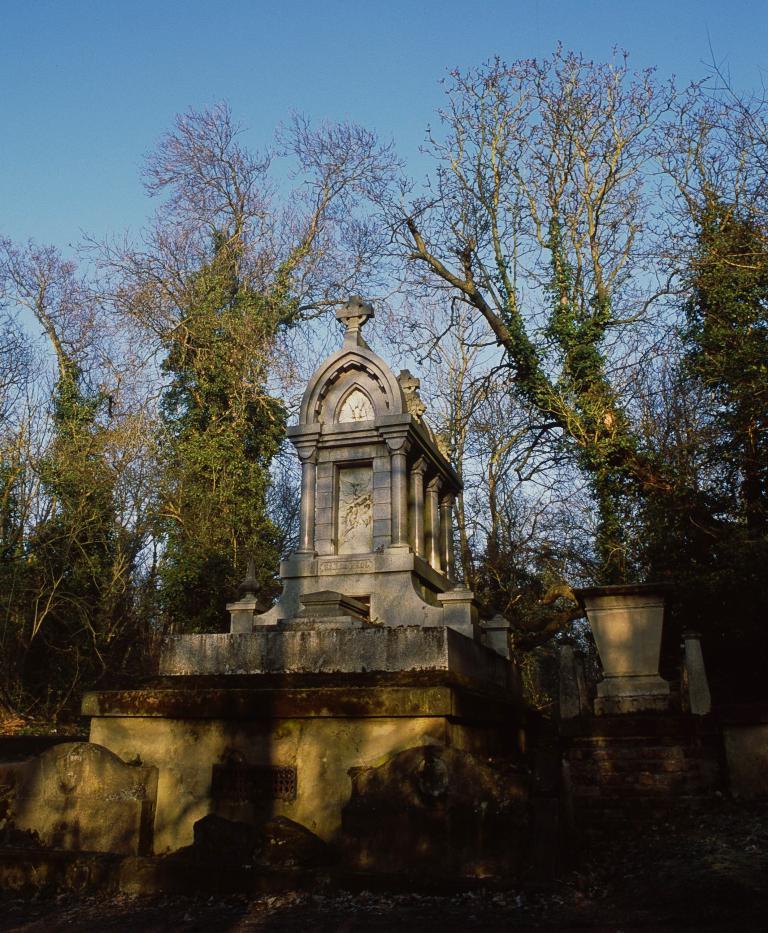How would you summarize this image in a sentence or two? In this image I can see there is a mausoleum. And it looks like a part of the building. And there are trees. And at the top there is a sky. 